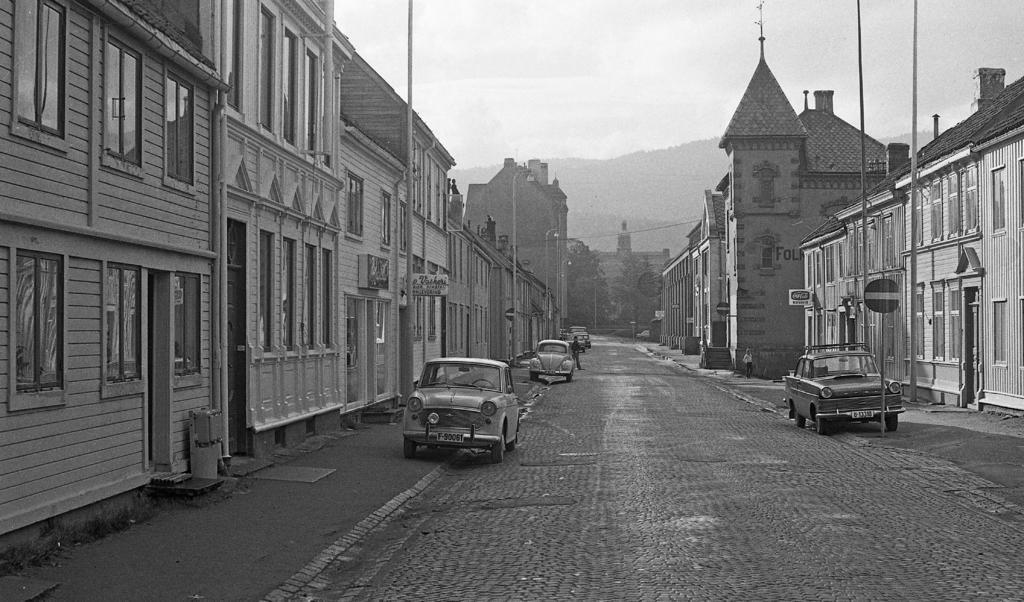Describe this image in one or two sentences. In this image I can see the road. On both sides of the road I can see the vehicles, people and the boards. I can also see the poles and buildings. In the background I can see the mountain and the sky. 